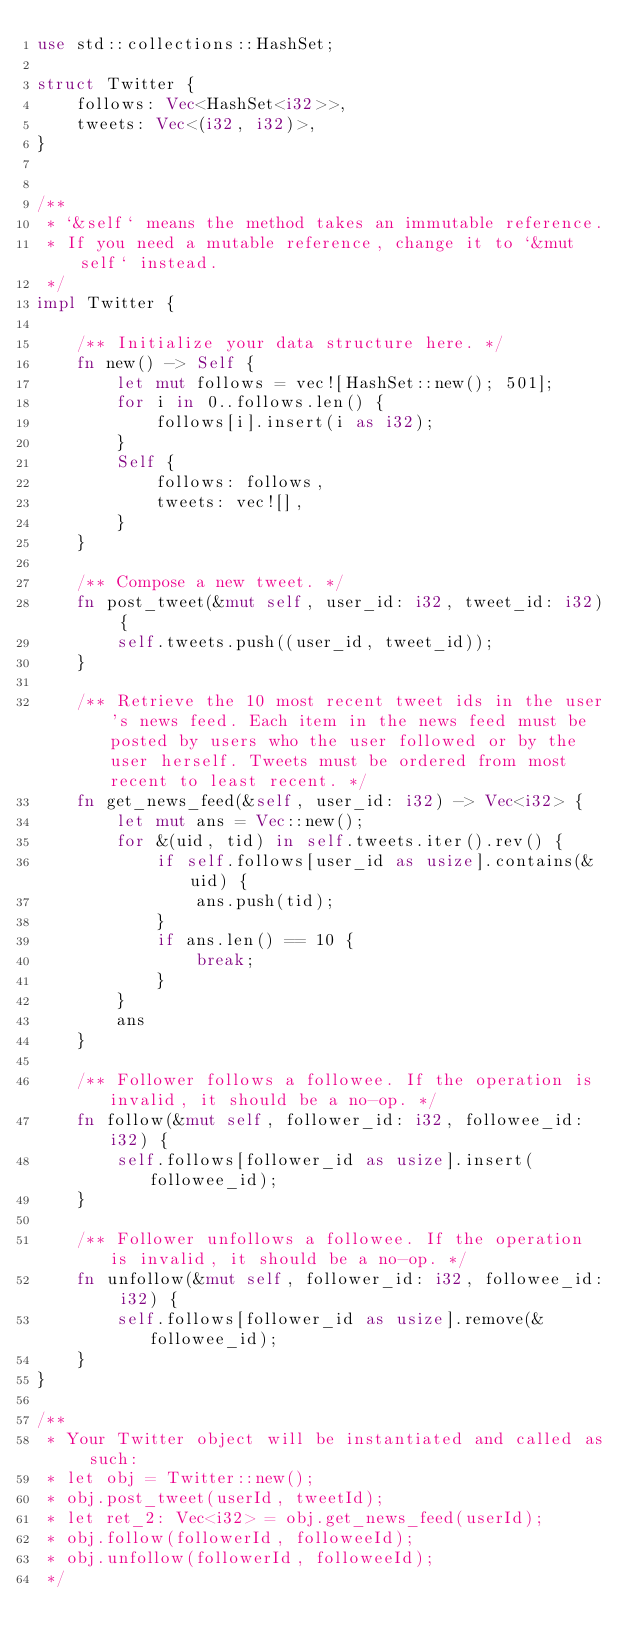Convert code to text. <code><loc_0><loc_0><loc_500><loc_500><_Rust_>use std::collections::HashSet;

struct Twitter {
    follows: Vec<HashSet<i32>>,
    tweets: Vec<(i32, i32)>,
}


/** 
 * `&self` means the method takes an immutable reference.
 * If you need a mutable reference, change it to `&mut self` instead.
 */
impl Twitter {

    /** Initialize your data structure here. */
    fn new() -> Self {
        let mut follows = vec![HashSet::new(); 501];
        for i in 0..follows.len() {
            follows[i].insert(i as i32);
        }
        Self {
            follows: follows,
            tweets: vec![],
        }
    }
    
    /** Compose a new tweet. */
    fn post_tweet(&mut self, user_id: i32, tweet_id: i32) {
        self.tweets.push((user_id, tweet_id));
    }
    
    /** Retrieve the 10 most recent tweet ids in the user's news feed. Each item in the news feed must be posted by users who the user followed or by the user herself. Tweets must be ordered from most recent to least recent. */
    fn get_news_feed(&self, user_id: i32) -> Vec<i32> {
        let mut ans = Vec::new();
        for &(uid, tid) in self.tweets.iter().rev() {            
            if self.follows[user_id as usize].contains(&uid) {
                ans.push(tid);
            }
            if ans.len() == 10 {
                break;
            }
        }
        ans
    }
    
    /** Follower follows a followee. If the operation is invalid, it should be a no-op. */
    fn follow(&mut self, follower_id: i32, followee_id: i32) {
        self.follows[follower_id as usize].insert(followee_id);
    }
    
    /** Follower unfollows a followee. If the operation is invalid, it should be a no-op. */
    fn unfollow(&mut self, follower_id: i32, followee_id: i32) {
        self.follows[follower_id as usize].remove(&followee_id);
    }
}

/**
 * Your Twitter object will be instantiated and called as such:
 * let obj = Twitter::new();
 * obj.post_tweet(userId, tweetId);
 * let ret_2: Vec<i32> = obj.get_news_feed(userId);
 * obj.follow(followerId, followeeId);
 * obj.unfollow(followerId, followeeId);
 */
</code> 